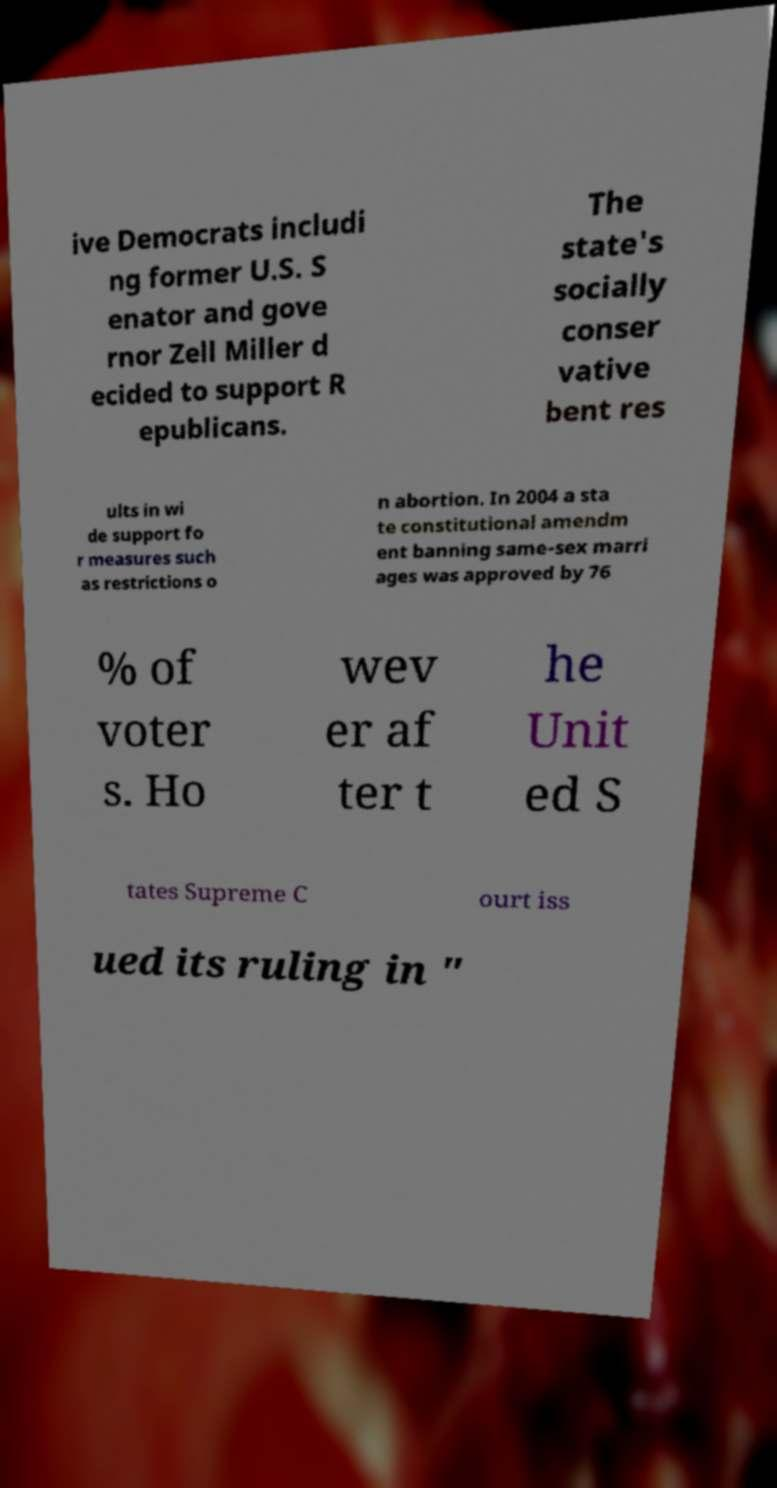What messages or text are displayed in this image? I need them in a readable, typed format. ive Democrats includi ng former U.S. S enator and gove rnor Zell Miller d ecided to support R epublicans. The state's socially conser vative bent res ults in wi de support fo r measures such as restrictions o n abortion. In 2004 a sta te constitutional amendm ent banning same-sex marri ages was approved by 76 % of voter s. Ho wev er af ter t he Unit ed S tates Supreme C ourt iss ued its ruling in " 